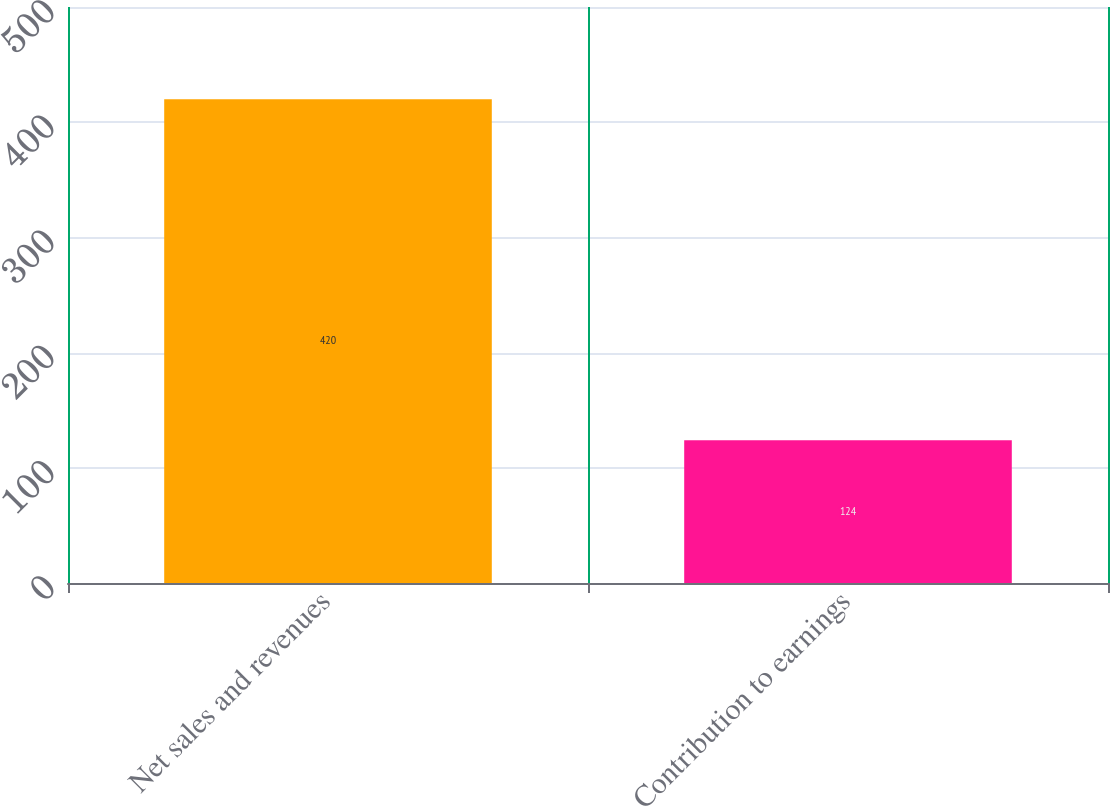Convert chart to OTSL. <chart><loc_0><loc_0><loc_500><loc_500><bar_chart><fcel>Net sales and revenues<fcel>Contribution to earnings<nl><fcel>420<fcel>124<nl></chart> 